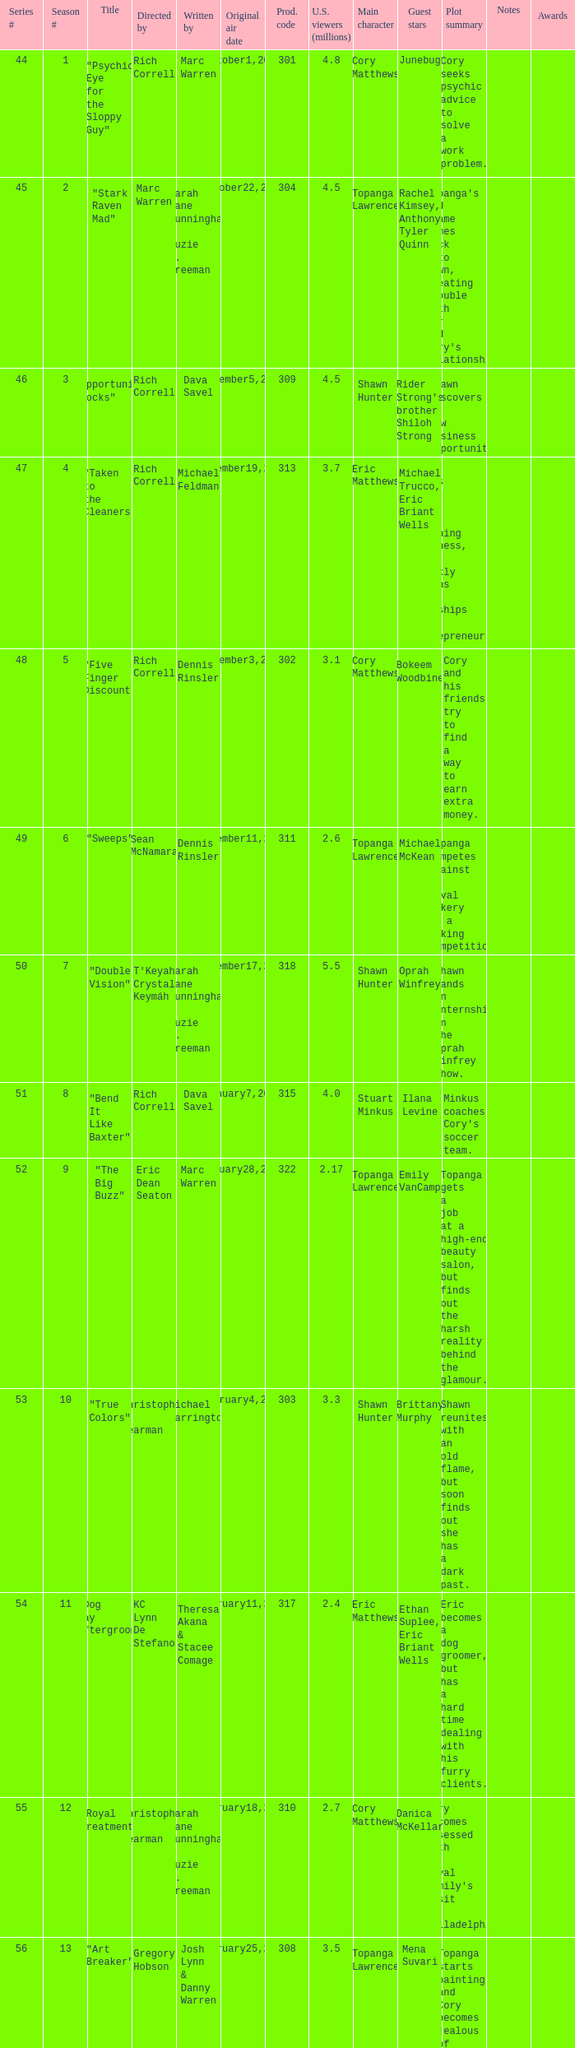What is the title of the episode directed by Rich Correll and written by Dennis Rinsler? "Five Finger Discount". 